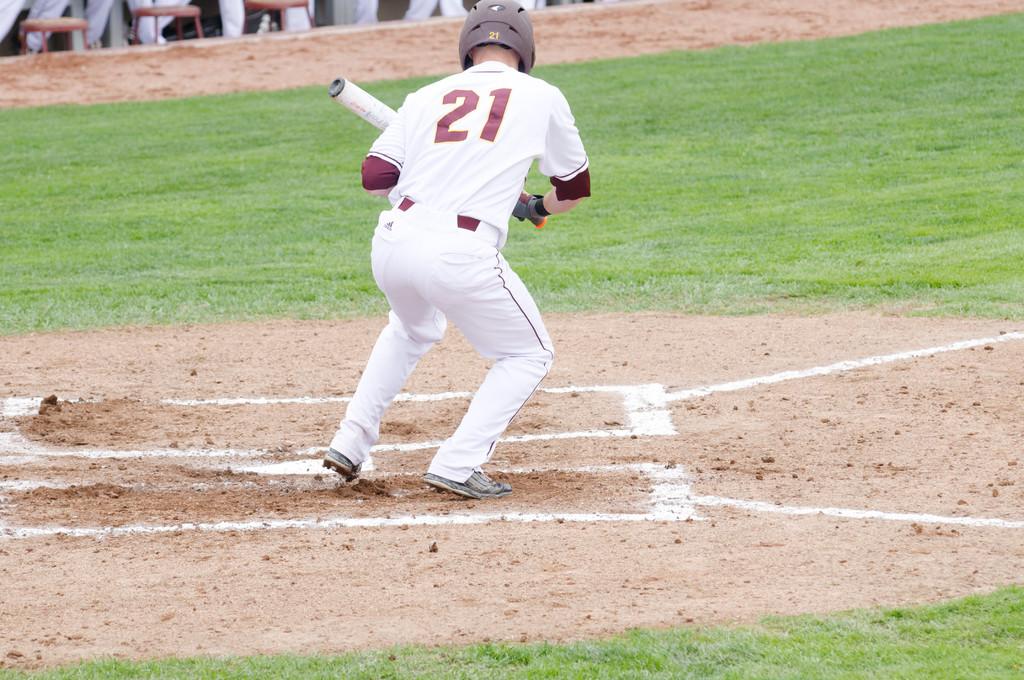What is the number on the players back?
Your answer should be very brief. 21. 